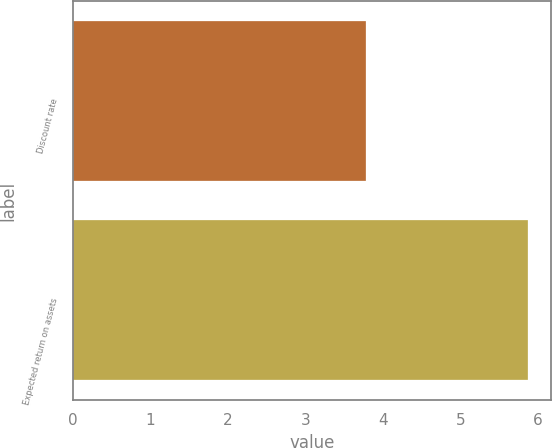<chart> <loc_0><loc_0><loc_500><loc_500><bar_chart><fcel>Discount rate<fcel>Expected return on assets<nl><fcel>3.78<fcel>5.87<nl></chart> 